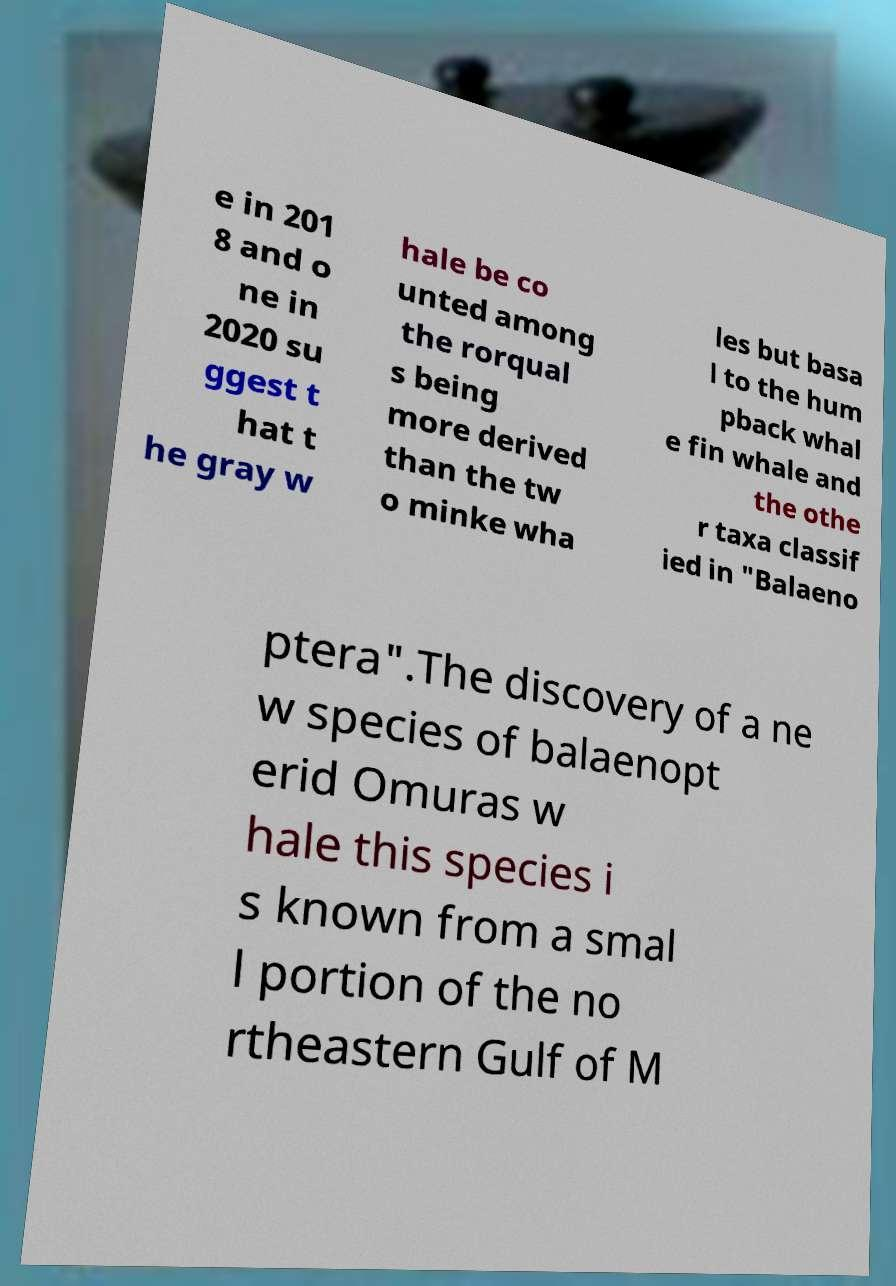I need the written content from this picture converted into text. Can you do that? e in 201 8 and o ne in 2020 su ggest t hat t he gray w hale be co unted among the rorqual s being more derived than the tw o minke wha les but basa l to the hum pback whal e fin whale and the othe r taxa classif ied in "Balaeno ptera".The discovery of a ne w species of balaenopt erid Omuras w hale this species i s known from a smal l portion of the no rtheastern Gulf of M 